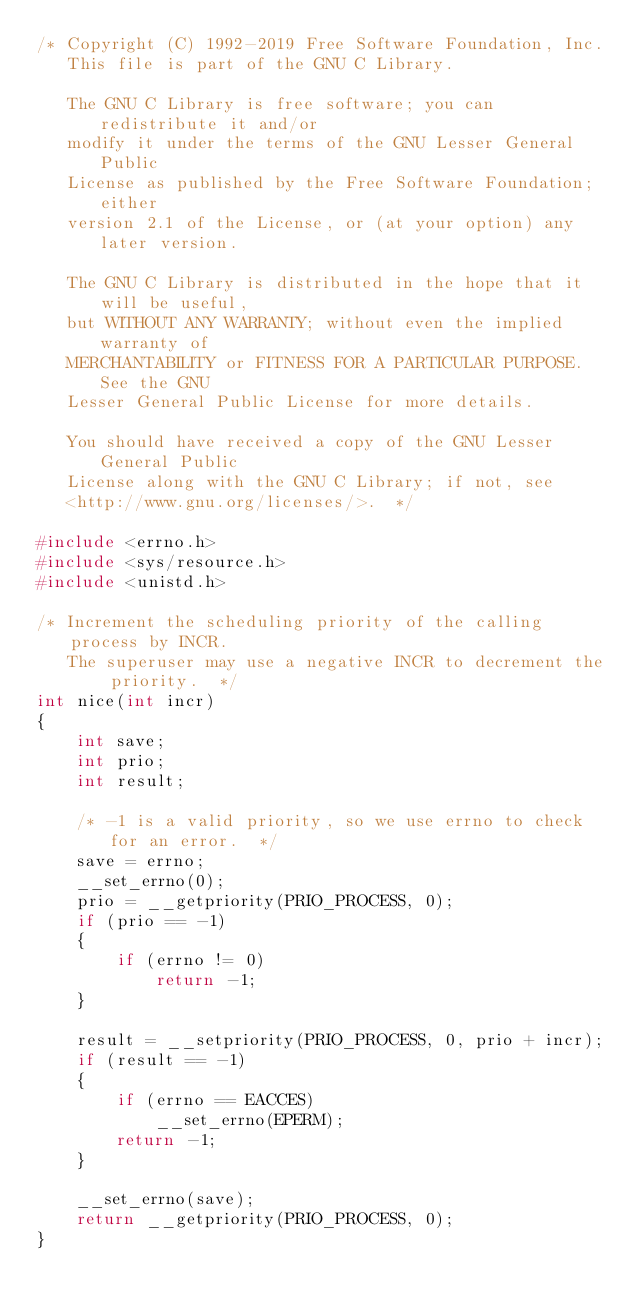<code> <loc_0><loc_0><loc_500><loc_500><_C_>/* Copyright (C) 1992-2019 Free Software Foundation, Inc.
   This file is part of the GNU C Library.

   The GNU C Library is free software; you can redistribute it and/or
   modify it under the terms of the GNU Lesser General Public
   License as published by the Free Software Foundation; either
   version 2.1 of the License, or (at your option) any later version.

   The GNU C Library is distributed in the hope that it will be useful,
   but WITHOUT ANY WARRANTY; without even the implied warranty of
   MERCHANTABILITY or FITNESS FOR A PARTICULAR PURPOSE.  See the GNU
   Lesser General Public License for more details.

   You should have received a copy of the GNU Lesser General Public
   License along with the GNU C Library; if not, see
   <http://www.gnu.org/licenses/>.  */

#include <errno.h>
#include <sys/resource.h>
#include <unistd.h>

/* Increment the scheduling priority of the calling process by INCR.
   The superuser may use a negative INCR to decrement the priority.  */
int nice(int incr)
{
    int save;
    int prio;
    int result;

    /* -1 is a valid priority, so we use errno to check for an error.  */
    save = errno;
    __set_errno(0);
    prio = __getpriority(PRIO_PROCESS, 0);
    if (prio == -1)
    {
        if (errno != 0)
            return -1;
    }

    result = __setpriority(PRIO_PROCESS, 0, prio + incr);
    if (result == -1)
    {
        if (errno == EACCES)
            __set_errno(EPERM);
        return -1;
    }

    __set_errno(save);
    return __getpriority(PRIO_PROCESS, 0);
}
</code> 